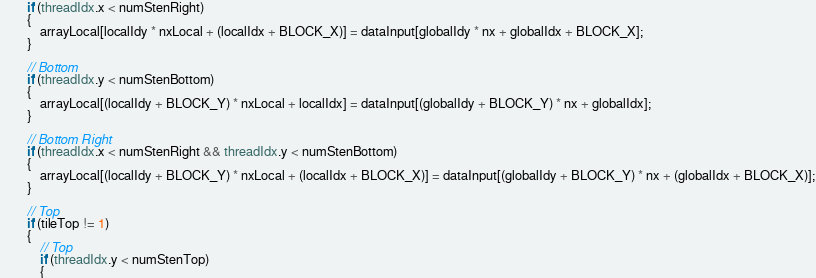Convert code to text. <code><loc_0><loc_0><loc_500><loc_500><_Cuda_>		if (threadIdx.x < numStenRight)
		{
			arrayLocal[localIdy * nxLocal + (localIdx + BLOCK_X)] = dataInput[globalIdy * nx + globalIdx + BLOCK_X];
		}

		// Bottom
		if (threadIdx.y < numStenBottom)
		{
			arrayLocal[(localIdy + BLOCK_Y) * nxLocal + localIdx] = dataInput[(globalIdy + BLOCK_Y) * nx + globalIdx];
		}

		// Bottom Right
		if (threadIdx.x < numStenRight && threadIdx.y < numStenBottom)
		{
			arrayLocal[(localIdy + BLOCK_Y) * nxLocal + (localIdx + BLOCK_X)] = dataInput[(globalIdy + BLOCK_Y) * nx + (globalIdx + BLOCK_X)];
		}

		// Top
		if (tileTop != 1)
		{	
			// Top
			if (threadIdx.y < numStenTop)
			{</code> 